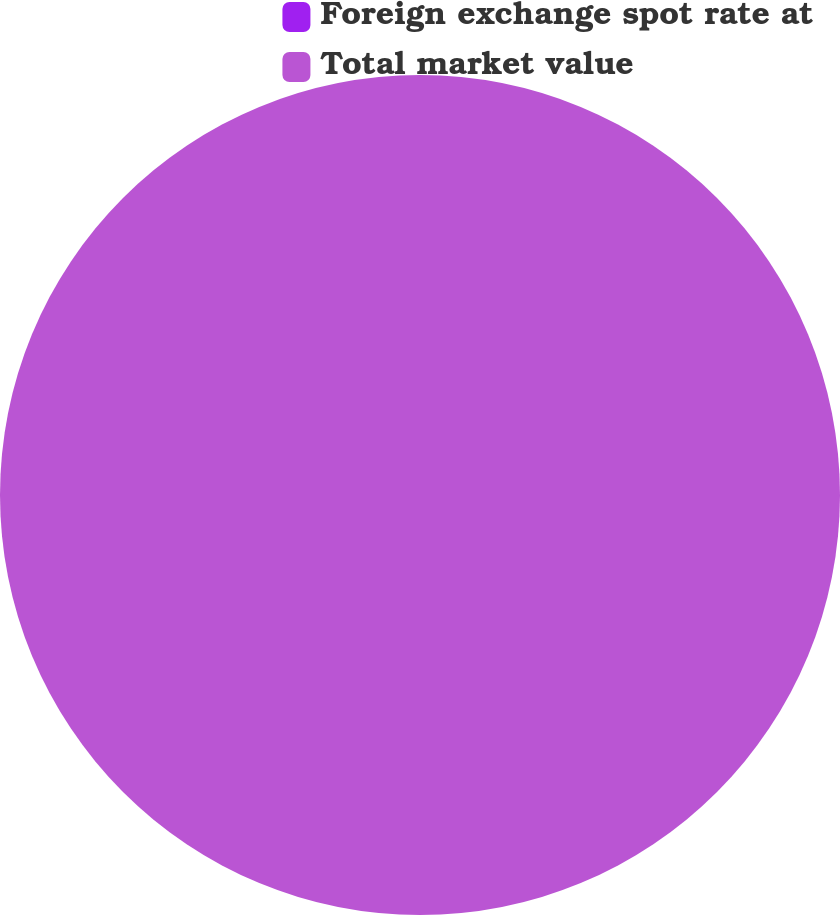Convert chart. <chart><loc_0><loc_0><loc_500><loc_500><pie_chart><fcel>Foreign exchange spot rate at<fcel>Total market value<nl><fcel>0.0%<fcel>100.0%<nl></chart> 